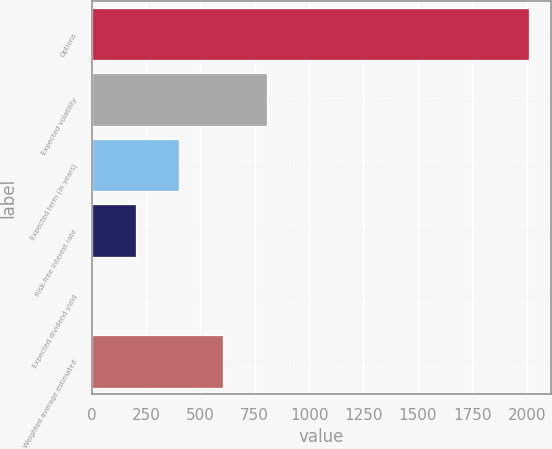<chart> <loc_0><loc_0><loc_500><loc_500><bar_chart><fcel>Options<fcel>Expected volatility<fcel>Expected term (in years)<fcel>Risk-free interest rate<fcel>Expected dividend yield<fcel>Weighted average estimated<nl><fcel>2010<fcel>805.37<fcel>403.81<fcel>203.03<fcel>2.25<fcel>604.59<nl></chart> 